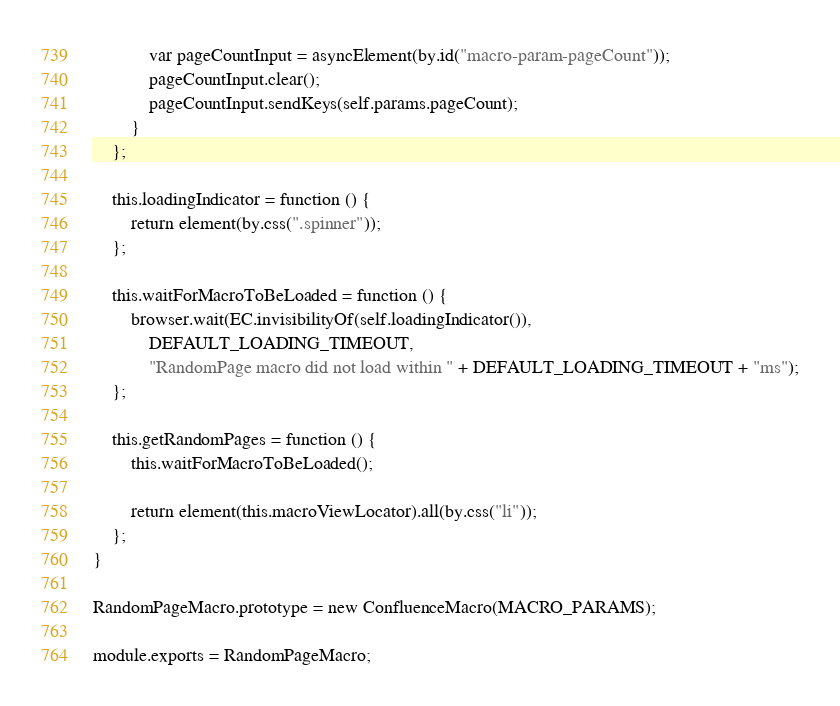<code> <loc_0><loc_0><loc_500><loc_500><_JavaScript_>			var pageCountInput = asyncElement(by.id("macro-param-pageCount"));
			pageCountInput.clear();
			pageCountInput.sendKeys(self.params.pageCount);
		}
	};

	this.loadingIndicator = function () {
		return element(by.css(".spinner"));
	};

	this.waitForMacroToBeLoaded = function () {
		browser.wait(EC.invisibilityOf(self.loadingIndicator()),
			DEFAULT_LOADING_TIMEOUT,
			"RandomPage macro did not load within " + DEFAULT_LOADING_TIMEOUT + "ms");
	};

	this.getRandomPages = function () {
		this.waitForMacroToBeLoaded();

		return element(this.macroViewLocator).all(by.css("li"));
	};
}

RandomPageMacro.prototype = new ConfluenceMacro(MACRO_PARAMS);

module.exports = RandomPageMacro;
</code> 